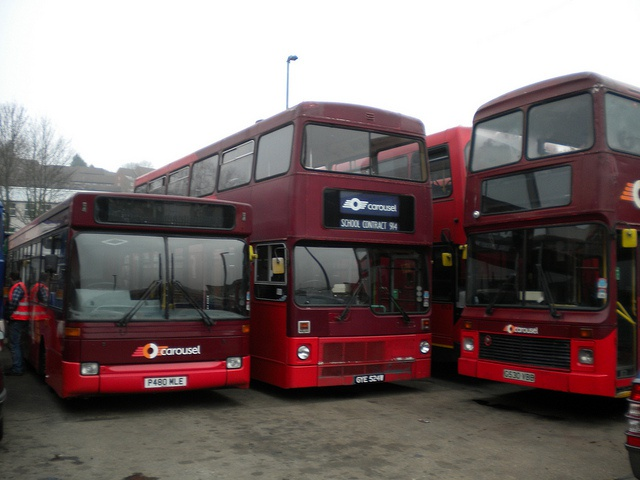Describe the objects in this image and their specific colors. I can see bus in white, black, maroon, gray, and darkgray tones, bus in lavender, black, gray, and maroon tones, bus in lavender, black, gray, and maroon tones, bus in white, black, maroon, and brown tones, and people in white, black, brown, maroon, and gray tones in this image. 